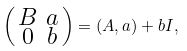<formula> <loc_0><loc_0><loc_500><loc_500>\left ( \begin{smallmatrix} B & a \\ 0 & b \end{smallmatrix} \right ) = ( A , a ) + b I ,</formula> 